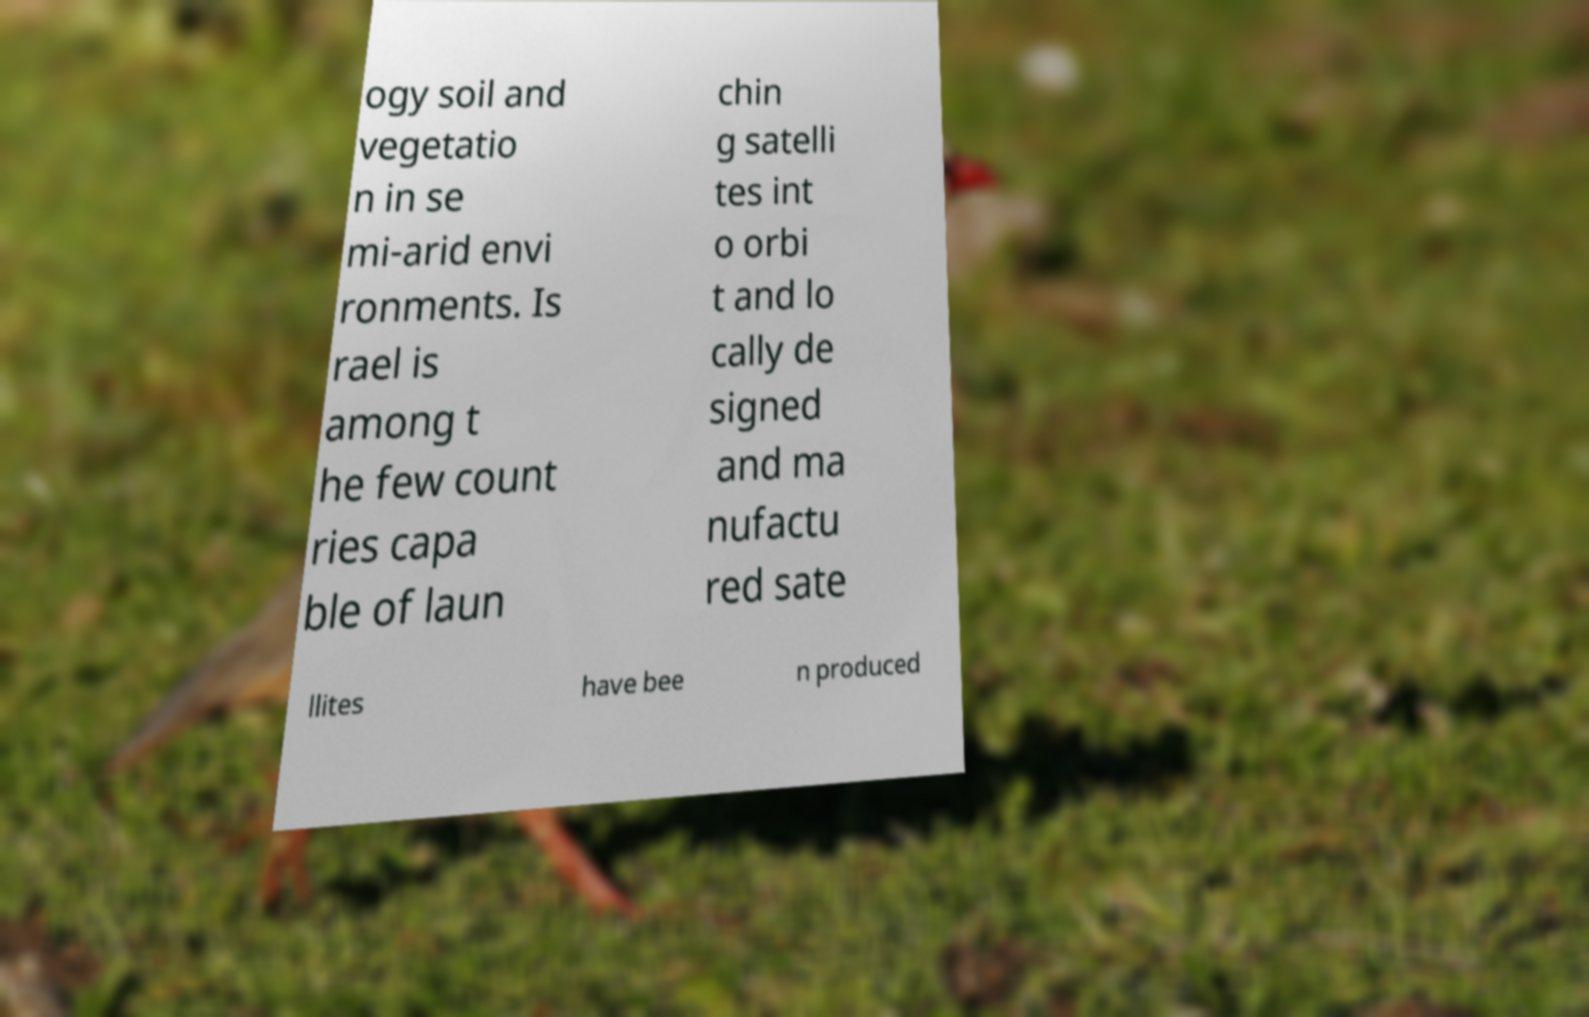I need the written content from this picture converted into text. Can you do that? ogy soil and vegetatio n in se mi-arid envi ronments. Is rael is among t he few count ries capa ble of laun chin g satelli tes int o orbi t and lo cally de signed and ma nufactu red sate llites have bee n produced 